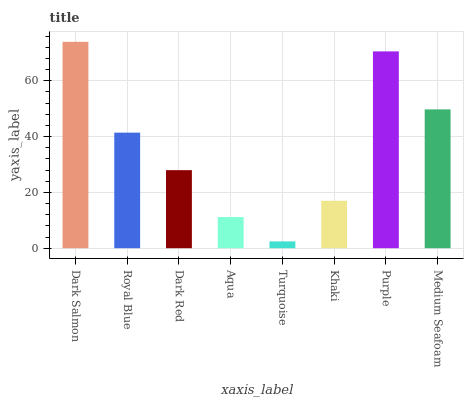Is Royal Blue the minimum?
Answer yes or no. No. Is Royal Blue the maximum?
Answer yes or no. No. Is Dark Salmon greater than Royal Blue?
Answer yes or no. Yes. Is Royal Blue less than Dark Salmon?
Answer yes or no. Yes. Is Royal Blue greater than Dark Salmon?
Answer yes or no. No. Is Dark Salmon less than Royal Blue?
Answer yes or no. No. Is Royal Blue the high median?
Answer yes or no. Yes. Is Dark Red the low median?
Answer yes or no. Yes. Is Medium Seafoam the high median?
Answer yes or no. No. Is Purple the low median?
Answer yes or no. No. 